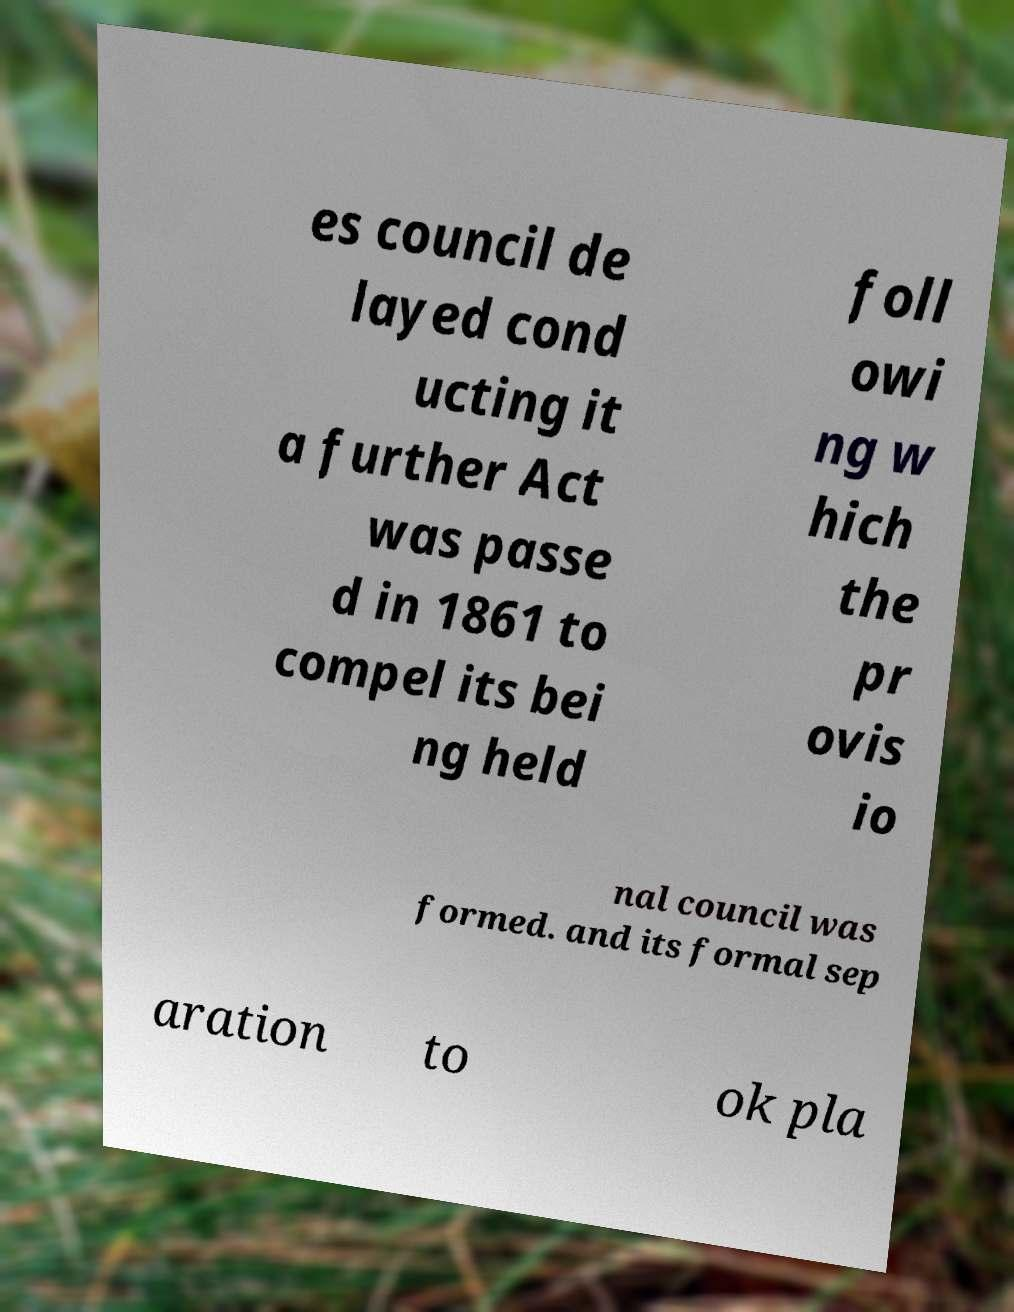I need the written content from this picture converted into text. Can you do that? es council de layed cond ucting it a further Act was passe d in 1861 to compel its bei ng held foll owi ng w hich the pr ovis io nal council was formed. and its formal sep aration to ok pla 